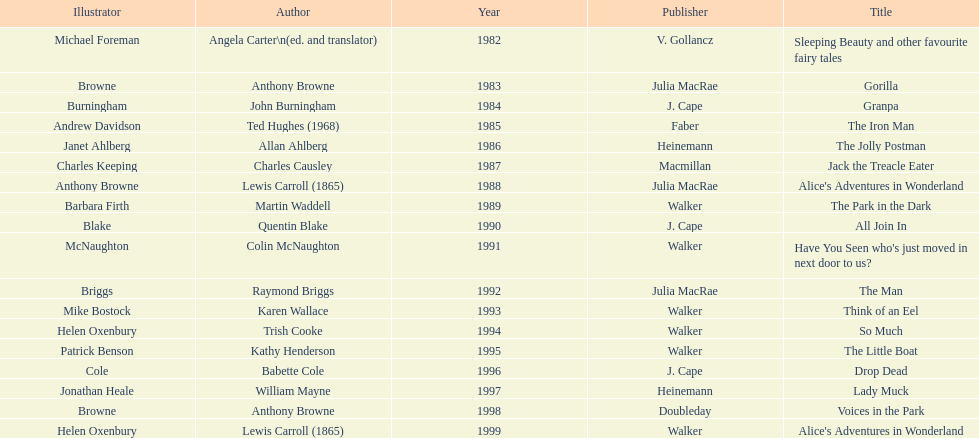How many times has anthony browne won an kurt maschler award for illustration? 3. 